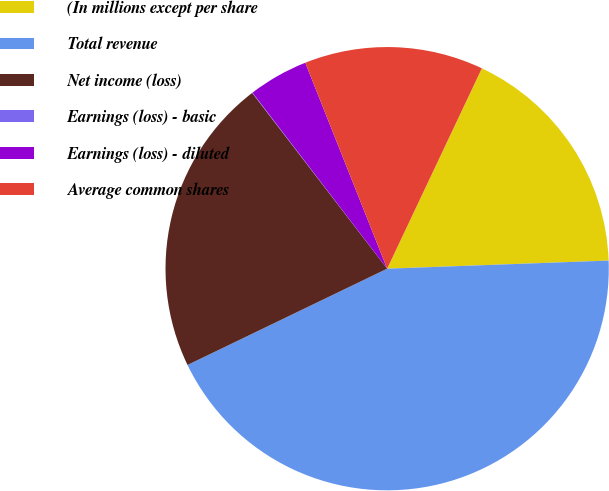Convert chart to OTSL. <chart><loc_0><loc_0><loc_500><loc_500><pie_chart><fcel>(In millions except per share<fcel>Total revenue<fcel>Net income (loss)<fcel>Earnings (loss) - basic<fcel>Earnings (loss) - diluted<fcel>Average common shares<nl><fcel>17.39%<fcel>43.43%<fcel>21.73%<fcel>0.03%<fcel>4.37%<fcel>13.05%<nl></chart> 